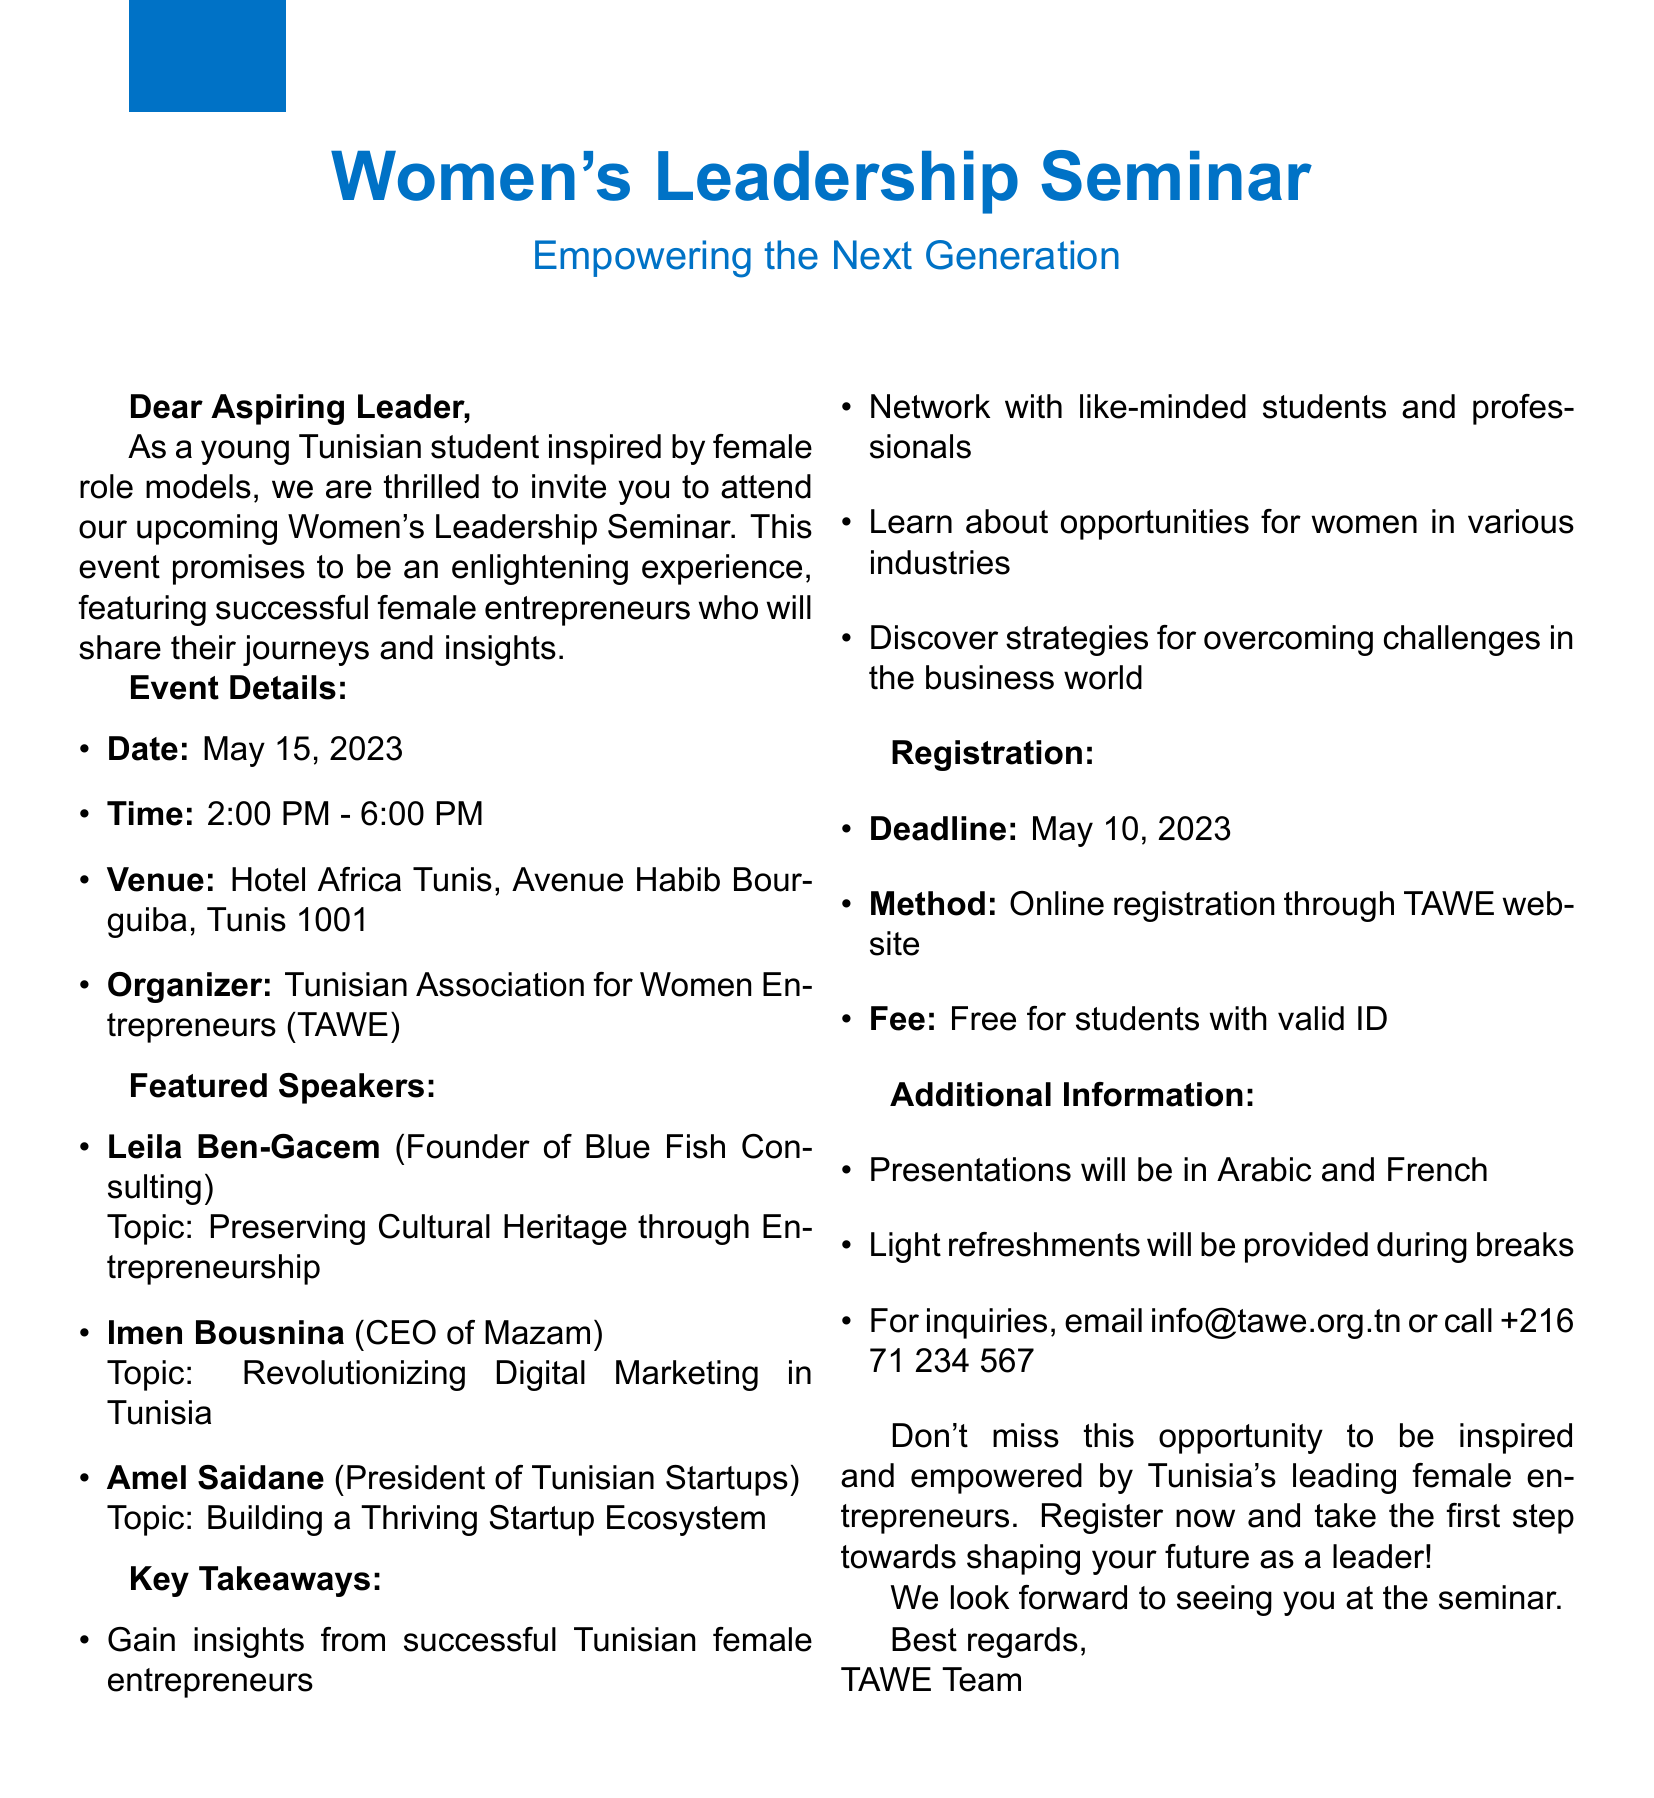what is the date of the seminar? The date of the seminar is specified in the document as May 15, 2023.
Answer: May 15, 2023 who is the organizer of the event? The organizer of the event is mentioned in the document as the Tunisian Association for Women Entrepreneurs (TAWE).
Answer: Tunisian Association for Women Entrepreneurs (TAWE) how many speakers are featured in the seminar? The document lists three speakers who will be featured in the seminar.
Answer: Three what is the registration deadline? The registration deadline is explicitly stated in the document as May 10, 2023.
Answer: May 10, 2023 what is the main topic of Leila Ben-Gacem's presentation? The document mentions that Leila Ben-Gacem will speak on the topic of preserving cultural heritage through entrepreneurship.
Answer: Preserving Cultural Heritage through Entrepreneurship which language will the presentations be in? The document indicates that presentations will be conducted in Arabic and French.
Answer: Arabic and French are refreshments provided during the seminar? The document confirms that light refreshments will be provided during breaks.
Answer: Light refreshments what is the fee for students to attend the seminar? According to the document, the fee for students with valid ID is free.
Answer: Free what contact method is provided for inquiries? The document provides an email and phone number for inquiries.
Answer: info@tawe.org.tn or +216 71 234 567 